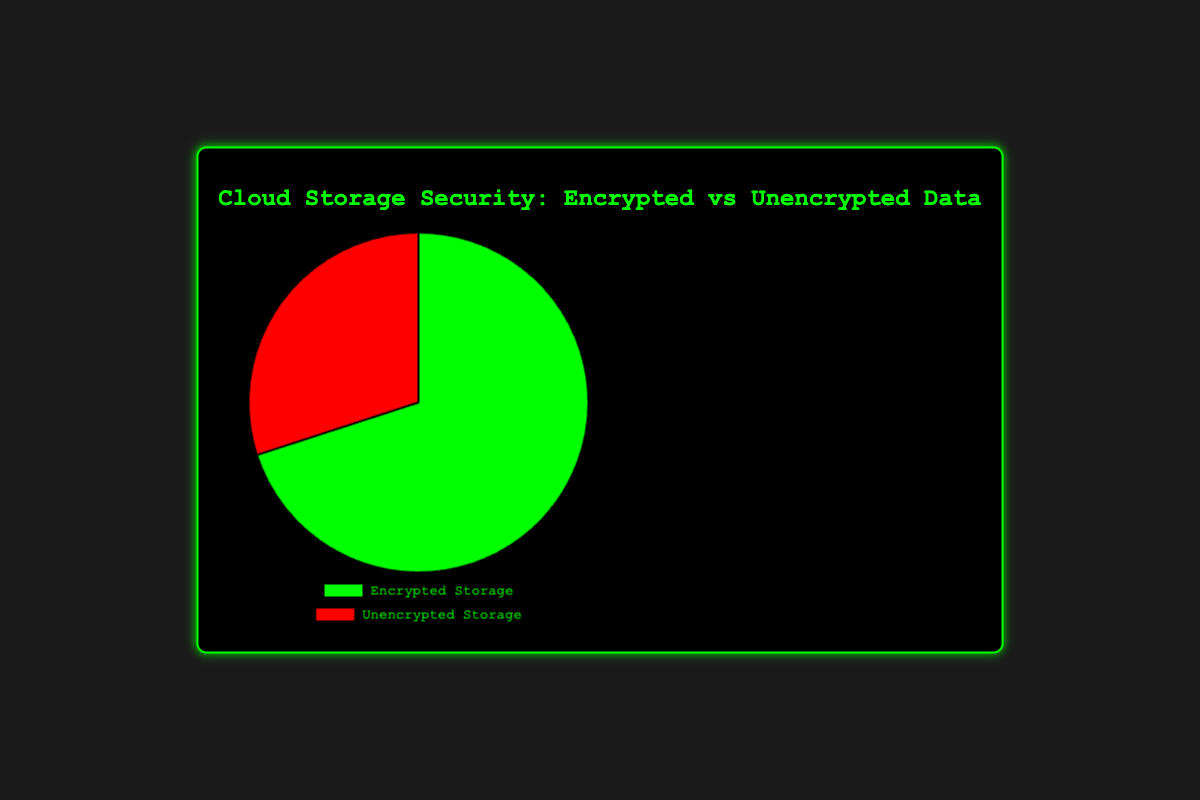Which category has the larger share of cloud storage? By observing the pie chart, it's clear that "Encrypted Storage" takes up a larger portion of the chart compared to "Unencrypted Storage".
Answer: Encrypted Storage What percentage of the cloud storage is encrypted? The pie chart indicates that "Encrypted Storage" covers 70% of the chart.
Answer: 70% Which category has a smaller share of cloud storage? By checking the pie chart, the "Unencrypted Storage" segment is noticeably smaller.
Answer: Unencrypted Storage What's the difference in percentage between encrypted and unencrypted storage data? Encrypted storage is 70% and unencrypted is 30%, so the difference is calculated as 70% - 30%.
Answer: 40% What is the sum of the percentages for encrypted and unencrypted storage? The percentage for encrypted storage is 70% and for unencrypted storage is 30%. Adding these together gives 70% + 30%.
Answer: 100% What color represents the encrypted storage in the pie chart? By looking at the pie chart, the segment for encrypted storage is colored green.
Answer: Green What color represents the unencrypted storage in the pie chart? By examining the pie chart, the segment for unencrypted storage is colored red.
Answer: Red How much more data is encrypted compared to unencrypted on AWS? The encrypted share is 70% and unencrypted share is 30%. The difference is calculated by subtracting 30% from 70%.
Answer: 40% How much more data is encrypted compared to unencrypted on Microsoft Azure? The encrypted share is 75% and unencrypted share is 25%. The difference is calculated by subtracting 25% from 75%.
Answer: 50% What is the average percentage of encrypted storage across AWS, GCP, and Azure? The encrypted percentages are 70% (AWS), 65% (GCP), and 75% (Azure). The average is calculated as (70 + 65 + 75) / 3.
Answer: 70% 